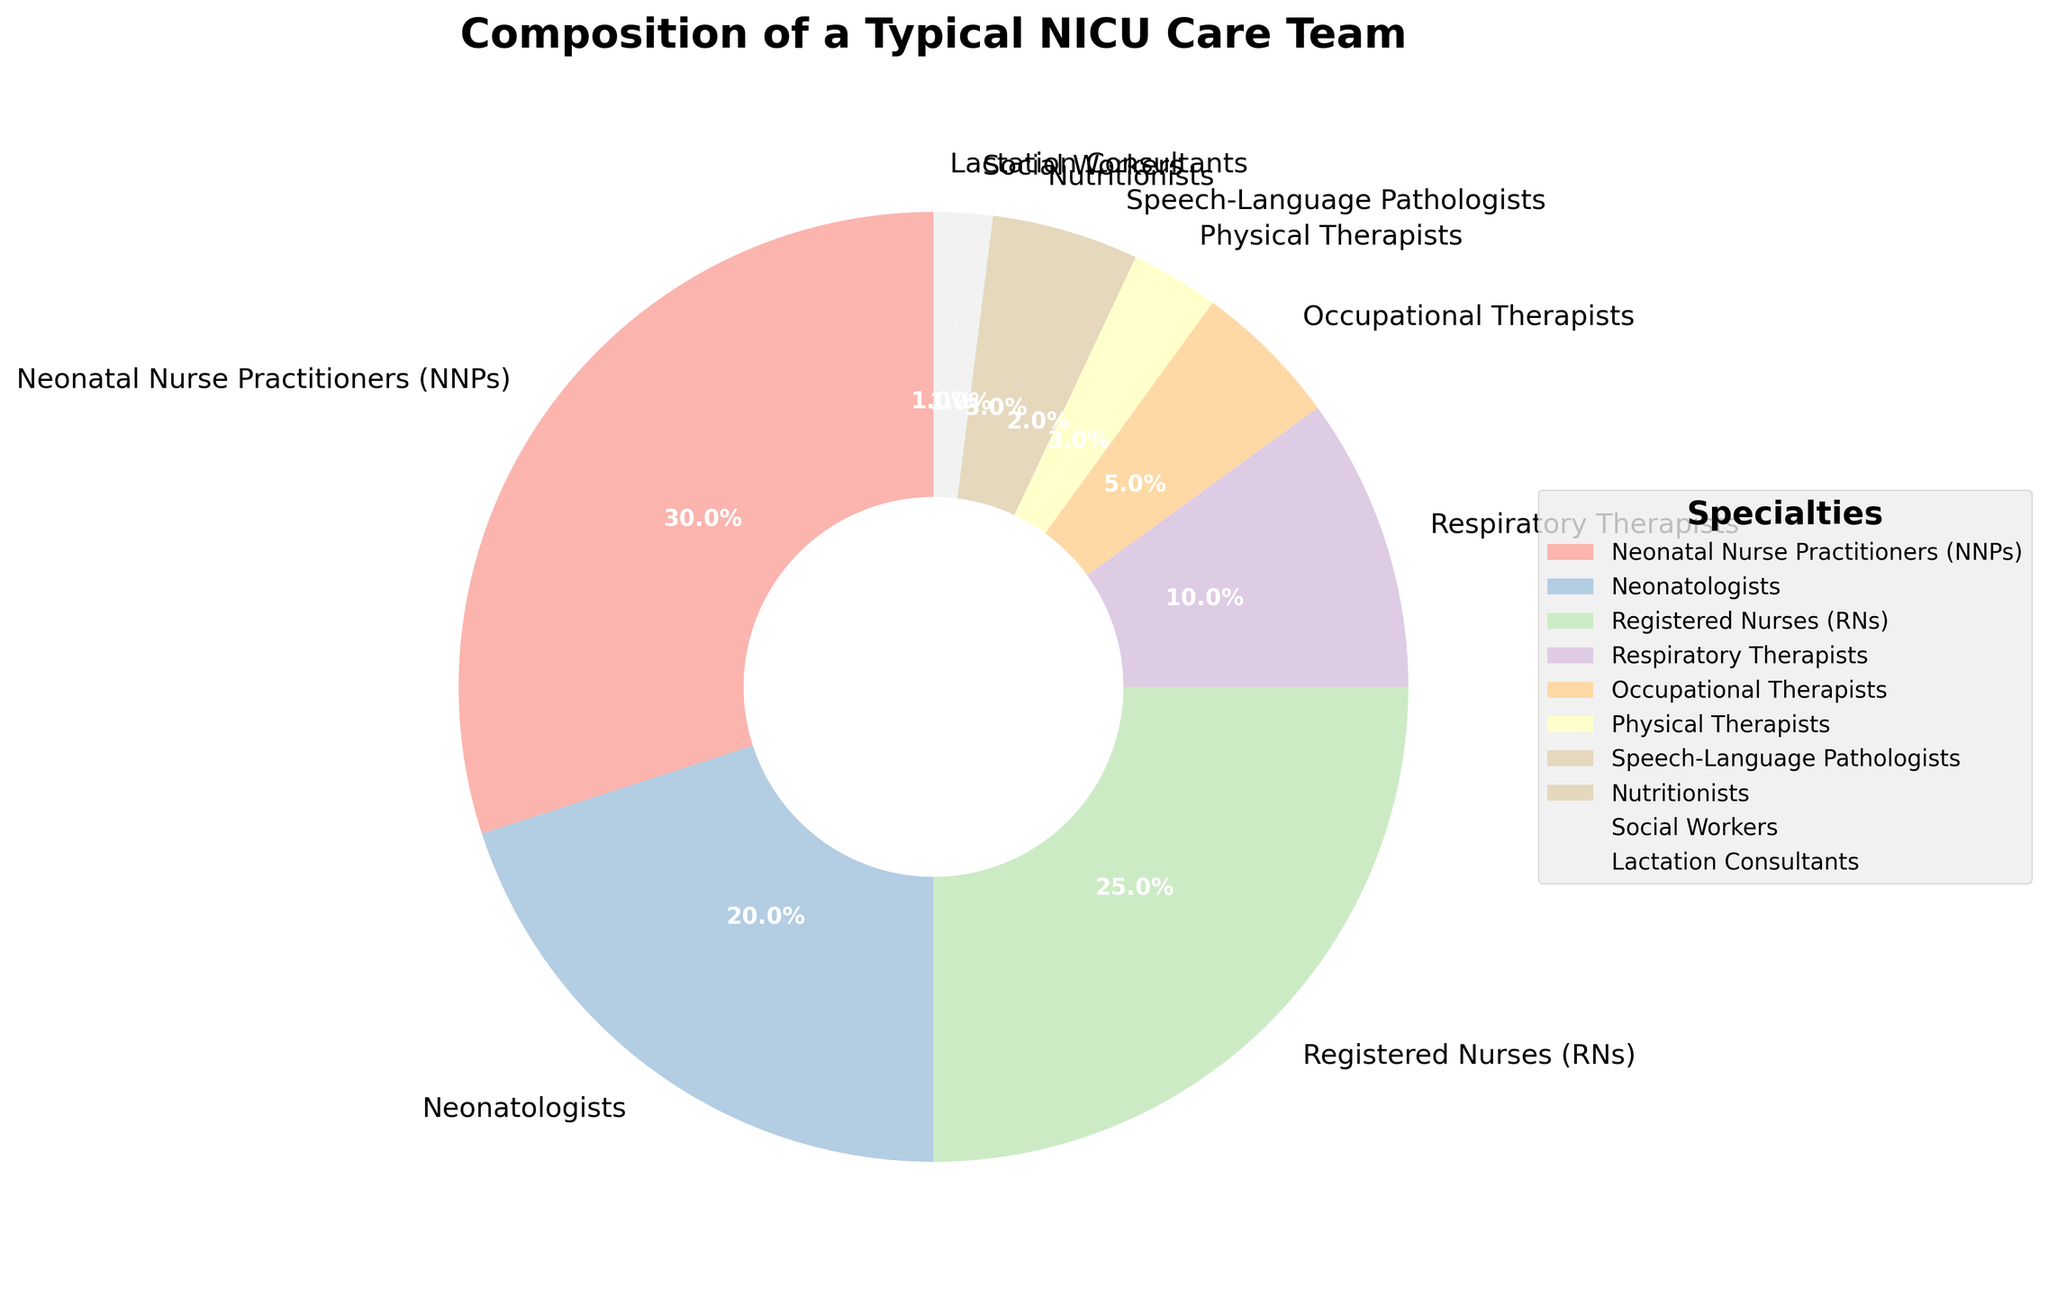What percentage of the NICU care team is composed of NNPs and RNs combined? To find the combined percentage of NNPs and RNs, add their individual percentages. NNPs contribute 30% and RNs contribute 25%. Therefore, 30% + 25% = 55%.
Answer: 55% Which specialty has a higher representation, Registered Nurses (RNs) or Neonatologists? Comparing the two percentages, RNs make up 25% of the team, while Neonatologists make up 20%. Since 25% is greater than 20%, RNs have a higher representation.
Answer: Registered Nurses (RNs) How much larger is the percentage of Respiratory Therapists compared to Social Workers and Lactation Consultants combined? Respiratory Therapists contribute 10% to the team, while Social Workers and Lactation Consultants contribute 1% each. First, find the combined percentage of Social Workers and Lactation Consultants: 1% + 1% = 2%. Then, subtract this from the percentage for Respiratory Therapists: 10% - 2% = 8%.
Answer: 8% Which specialty group is visually represented as the smallest wedge in the pie chart? By looking at the pie chart, the segment representing the smallest percentage will appear as the smallest wedge. Social Workers and Lactation Consultants each make up 1%, the least among all specialties, so they will be the smallest wedges.
Answer: Social Workers and Lactation Consultants Is the combined representation of Occupational Therapists, Physical Therapists, and Nutritionists more or less than that of Respiratory Therapists? Add the percentages of Occupational Therapists (5%), Physical Therapists (3%), and Nutritionists (3%): 5% + 3% + 3% = 11%. Compare this sum with the percentage for Respiratory Therapists, which is 10%. Since 11% is greater than 10%, the combined representation is more.
Answer: More What is the total percentage of the NICU care team represented by those in therapeutic roles (Occupational Therapists, Physical Therapists, Speech-Language Pathologists, and Respiratory Therapists)? Add the percentages of all therapeutic roles: Occupational Therapists (5%), Physical Therapists (3%), Speech-Language Pathologists (2%), and Respiratory Therapists (10%). The sum is 5% + 3% + 2% + 10% = 20%.
Answer: 20% Which color is used to represent Neonatologists in the pie chart? To determine the color representing Neonatologists, locate the segment labeled "Neonatologists" in the pie chart and observe its color. This segment’s color in the visual representation will correspond to the label.
Answer: (This would be answered by visual confirmation but without that, let's skip) Would combining Lactation Consultants and Social Workers equal the representation of Physical Therapists? Lactation Consultants contribute 1% and Social Workers also contribute 1%, leading to a combined contribution of 1% + 1% = 2%. Physical Therapists contribute 3%, so the combined representation is less than that of Physical Therapists.
Answer: No Out of NNPs, Neonatologists, and Registered Nurses, which specialty has the second-highest representation? Compare the percentages: NNPs (30%), Neonatologists (20%), and RNs (25%). Registered Nurses have the second-highest percentage.
Answer: Registered Nurses (RNs) 